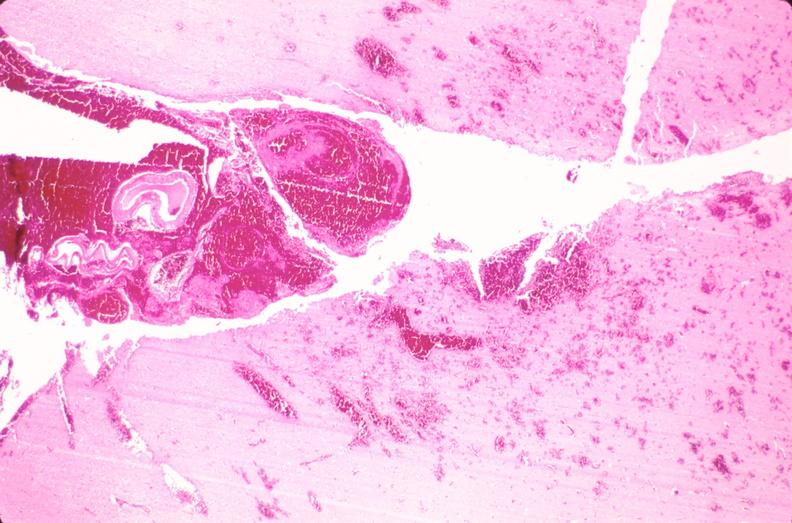does this image show brain, subarachanoid hemorrhage and hematoma due to ruptured aneurysm?
Answer the question using a single word or phrase. Yes 